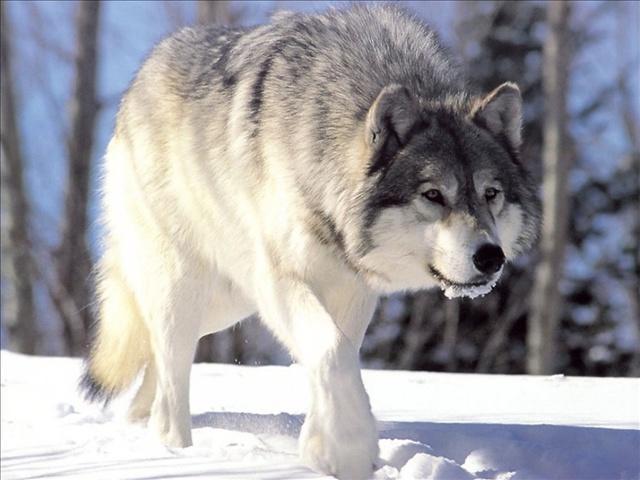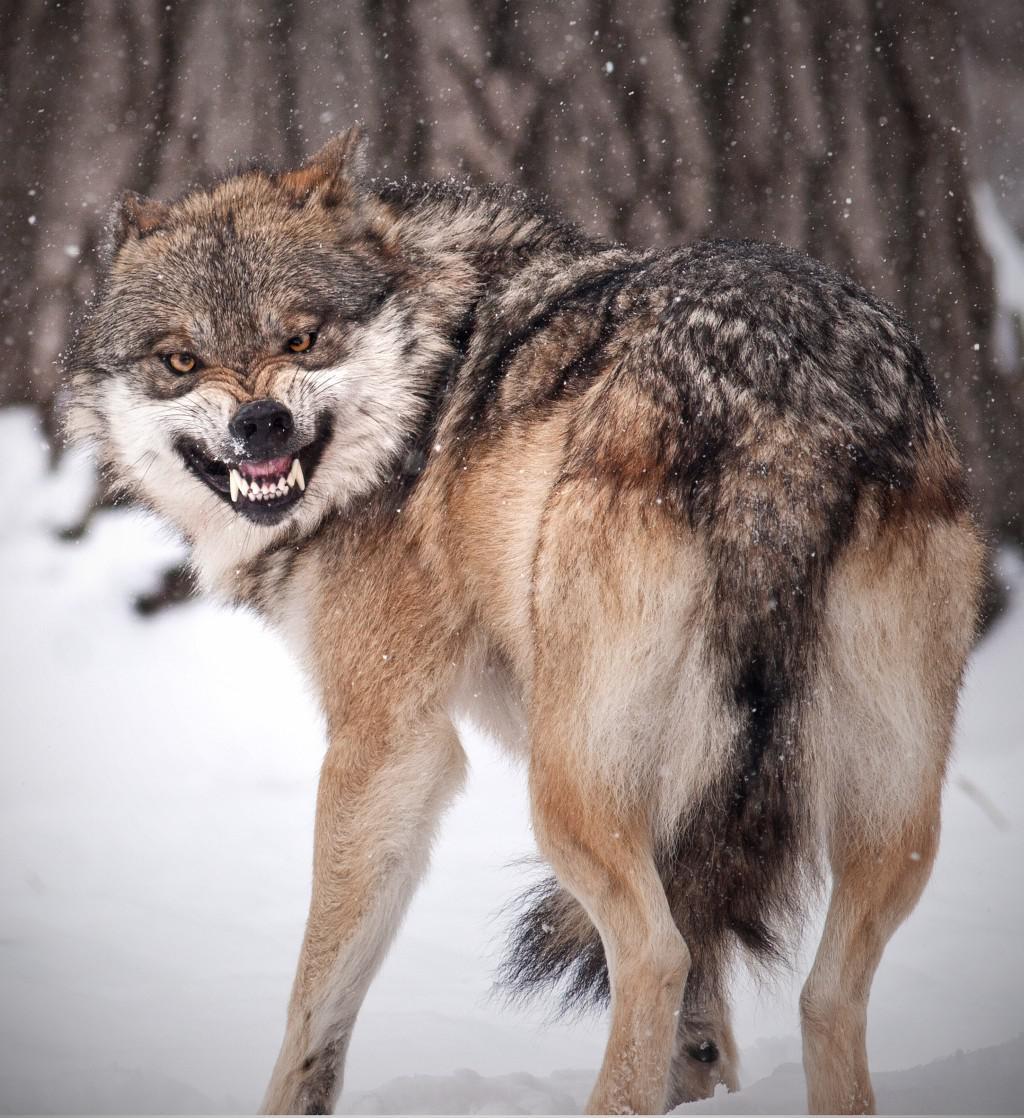The first image is the image on the left, the second image is the image on the right. Evaluate the accuracy of this statement regarding the images: "There are two wolves in the right image.". Is it true? Answer yes or no. No. The first image is the image on the left, the second image is the image on the right. Considering the images on both sides, is "there are wolves with teeth bared in a snarl" valid? Answer yes or no. Yes. 